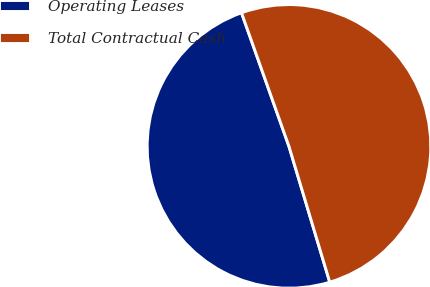<chart> <loc_0><loc_0><loc_500><loc_500><pie_chart><fcel>Operating Leases<fcel>Total Contractual Cash<nl><fcel>49.21%<fcel>50.79%<nl></chart> 